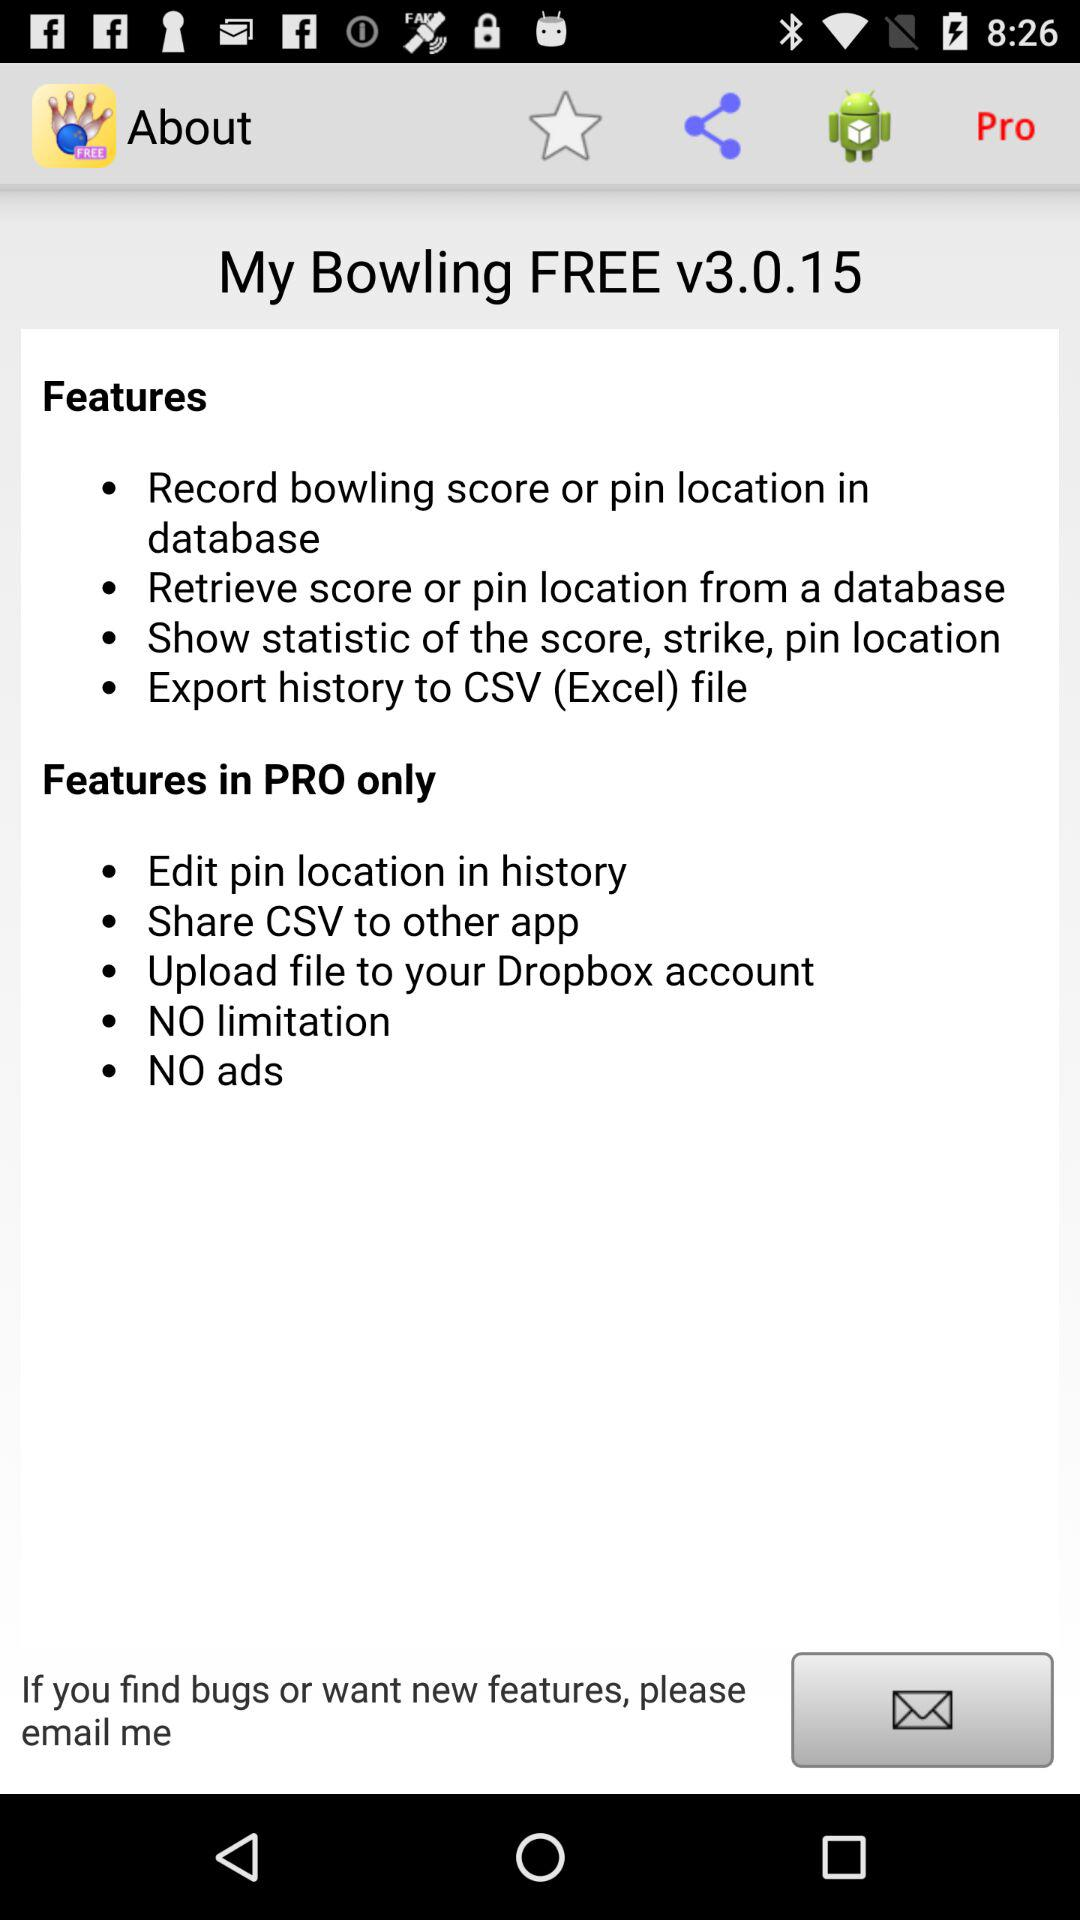What is the name of the application? The name of the application is "My Bowling Scoreboard Free". 